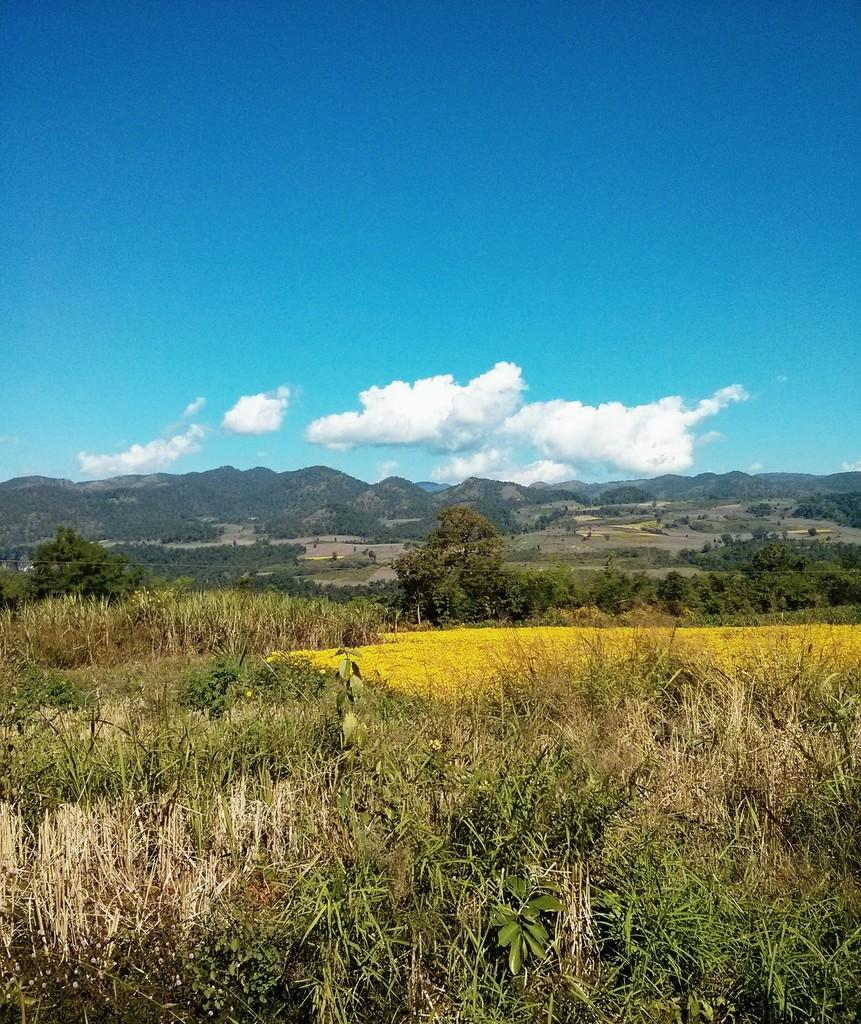What type of vegetation can be seen in the image? There is grass, plants, and trees in the image. What type of terrain is visible in the image? There are hills in the image. What is visible in the background of the image? The sky is visible in the background of the image. Can you see any frogs in the image? There are no frogs present in the image. What type of bait is used to catch the fish in the image? There are no fish or bait present in the image. 